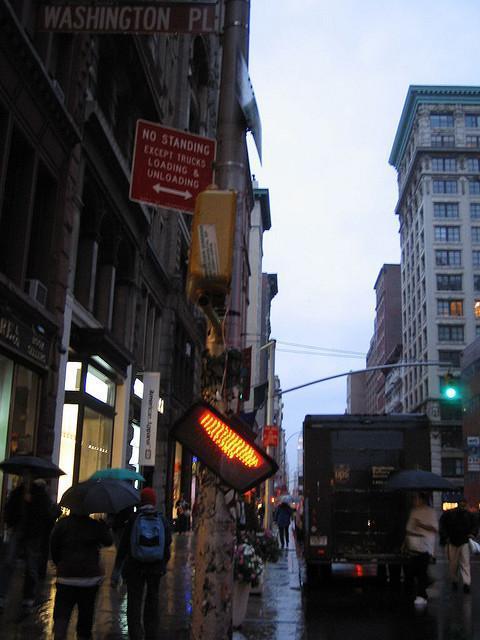How many potted plants are there?
Give a very brief answer. 1. How many people are there?
Give a very brief answer. 5. 